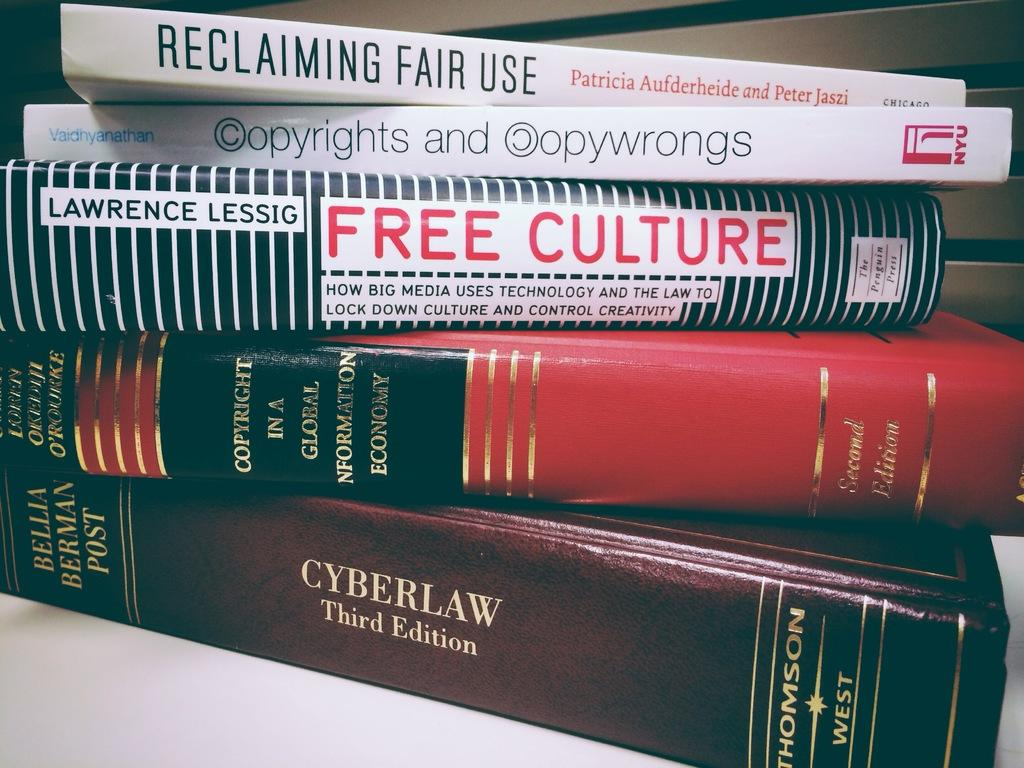<image>
Render a clear and concise summary of the photo. Five law books concerned with cyber law lie horizontally on top of each other. 